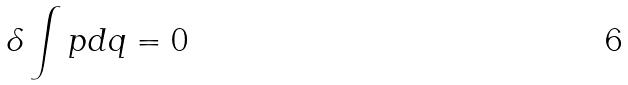Convert formula to latex. <formula><loc_0><loc_0><loc_500><loc_500>\delta \int p d q = 0</formula> 